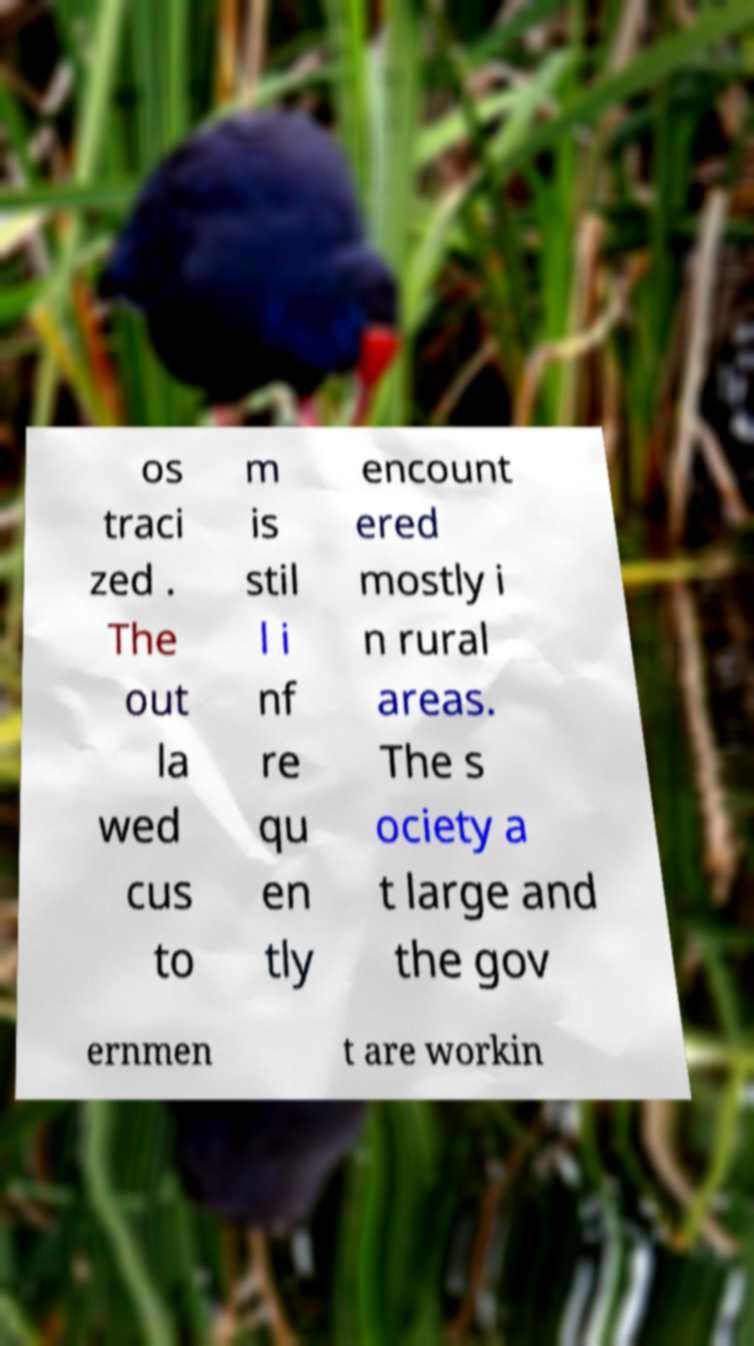What messages or text are displayed in this image? I need them in a readable, typed format. os traci zed . The out la wed cus to m is stil l i nf re qu en tly encount ered mostly i n rural areas. The s ociety a t large and the gov ernmen t are workin 